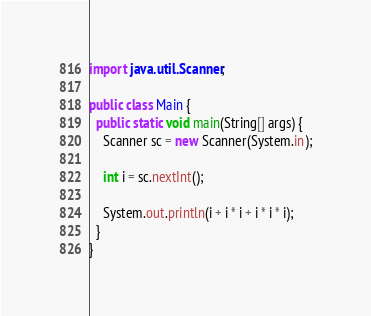Convert code to text. <code><loc_0><loc_0><loc_500><loc_500><_Java_>import java.util.Scanner;

public class Main {
  public static void main(String[] args) {
    Scanner sc = new Scanner(System.in);
    
    int i = sc.nextInt();
    
    System.out.println(i + i * i + i * i * i);
  }
}</code> 